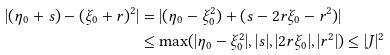Convert formula to latex. <formula><loc_0><loc_0><loc_500><loc_500>| ( \eta _ { 0 } + s ) - ( \xi _ { 0 } + r ) ^ { 2 } | & = | ( \eta _ { 0 } - \xi _ { 0 } ^ { 2 } ) + ( s - 2 r \xi _ { 0 } - r ^ { 2 } ) | \\ & \leq \max ( | \eta _ { 0 } - \xi _ { 0 } ^ { 2 } | , | s | , | 2 r \xi _ { 0 } | , | r ^ { 2 } | ) \leq | J | ^ { 2 }</formula> 